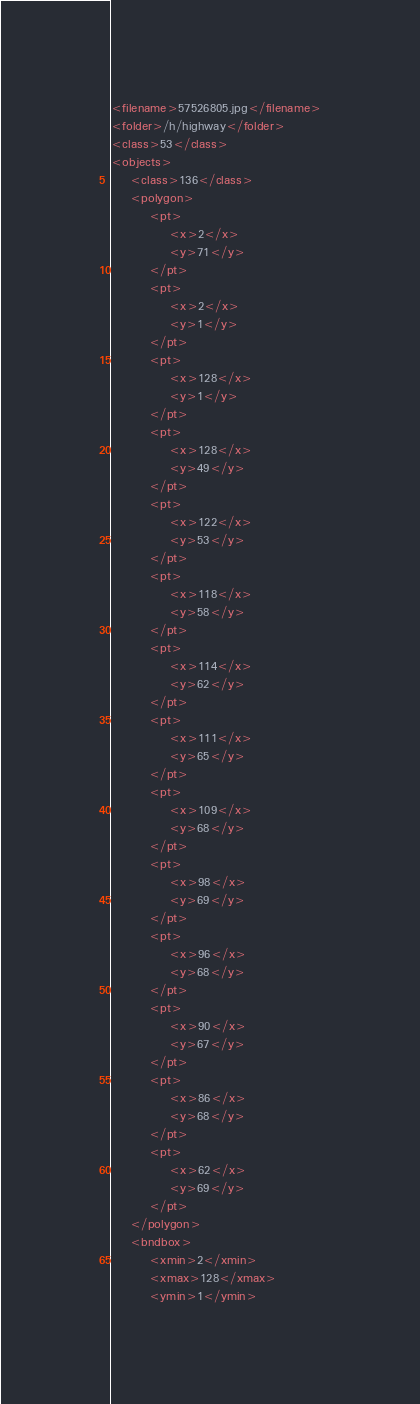Convert code to text. <code><loc_0><loc_0><loc_500><loc_500><_XML_><filename>57526805.jpg</filename>
<folder>/h/highway</folder>
<class>53</class>
<objects>
	<class>136</class>
	<polygon>
		<pt>
			<x>2</x>
			<y>71</y>
		</pt>
		<pt>
			<x>2</x>
			<y>1</y>
		</pt>
		<pt>
			<x>128</x>
			<y>1</y>
		</pt>
		<pt>
			<x>128</x>
			<y>49</y>
		</pt>
		<pt>
			<x>122</x>
			<y>53</y>
		</pt>
		<pt>
			<x>118</x>
			<y>58</y>
		</pt>
		<pt>
			<x>114</x>
			<y>62</y>
		</pt>
		<pt>
			<x>111</x>
			<y>65</y>
		</pt>
		<pt>
			<x>109</x>
			<y>68</y>
		</pt>
		<pt>
			<x>98</x>
			<y>69</y>
		</pt>
		<pt>
			<x>96</x>
			<y>68</y>
		</pt>
		<pt>
			<x>90</x>
			<y>67</y>
		</pt>
		<pt>
			<x>86</x>
			<y>68</y>
		</pt>
		<pt>
			<x>62</x>
			<y>69</y>
		</pt>
	</polygon>
	<bndbox>
		<xmin>2</xmin>
		<xmax>128</xmax>
		<ymin>1</ymin></code> 